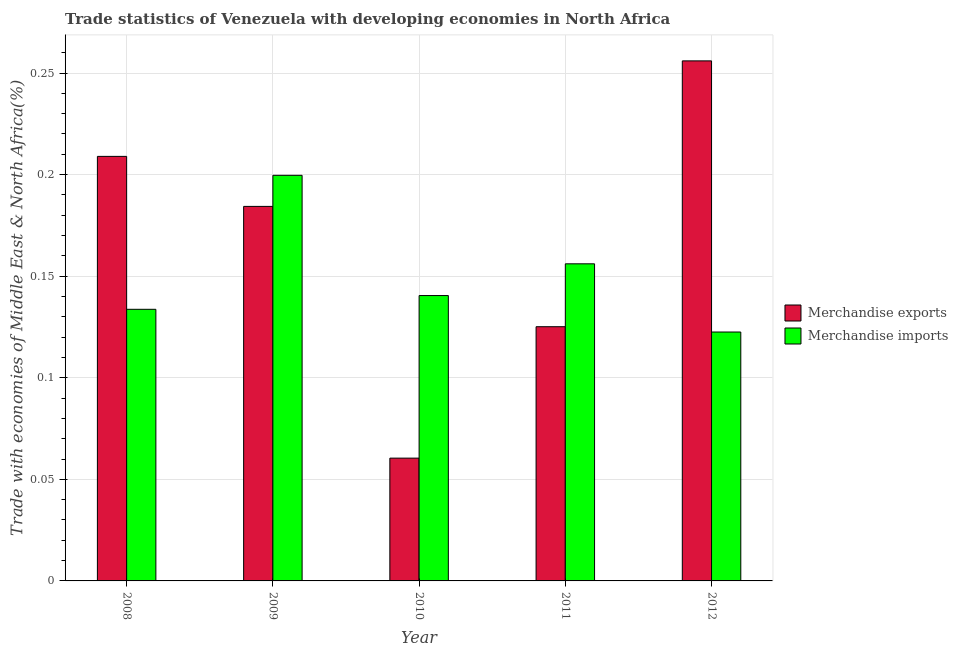Are the number of bars on each tick of the X-axis equal?
Provide a succinct answer. Yes. How many bars are there on the 3rd tick from the left?
Ensure brevity in your answer.  2. What is the label of the 2nd group of bars from the left?
Keep it short and to the point. 2009. What is the merchandise imports in 2010?
Ensure brevity in your answer.  0.14. Across all years, what is the maximum merchandise imports?
Provide a short and direct response. 0.2. Across all years, what is the minimum merchandise exports?
Ensure brevity in your answer.  0.06. In which year was the merchandise exports minimum?
Provide a short and direct response. 2010. What is the total merchandise imports in the graph?
Keep it short and to the point. 0.75. What is the difference between the merchandise imports in 2009 and that in 2010?
Give a very brief answer. 0.06. What is the difference between the merchandise imports in 2012 and the merchandise exports in 2008?
Ensure brevity in your answer.  -0.01. What is the average merchandise exports per year?
Provide a succinct answer. 0.17. What is the ratio of the merchandise exports in 2008 to that in 2009?
Make the answer very short. 1.13. What is the difference between the highest and the second highest merchandise imports?
Give a very brief answer. 0.04. What is the difference between the highest and the lowest merchandise imports?
Your response must be concise. 0.08. In how many years, is the merchandise imports greater than the average merchandise imports taken over all years?
Keep it short and to the point. 2. What does the 2nd bar from the left in 2008 represents?
Your answer should be very brief. Merchandise imports. What is the difference between two consecutive major ticks on the Y-axis?
Keep it short and to the point. 0.05. Are the values on the major ticks of Y-axis written in scientific E-notation?
Your answer should be very brief. No. How many legend labels are there?
Provide a succinct answer. 2. How are the legend labels stacked?
Provide a succinct answer. Vertical. What is the title of the graph?
Provide a short and direct response. Trade statistics of Venezuela with developing economies in North Africa. What is the label or title of the Y-axis?
Provide a short and direct response. Trade with economies of Middle East & North Africa(%). What is the Trade with economies of Middle East & North Africa(%) of Merchandise exports in 2008?
Your answer should be compact. 0.21. What is the Trade with economies of Middle East & North Africa(%) in Merchandise imports in 2008?
Your response must be concise. 0.13. What is the Trade with economies of Middle East & North Africa(%) in Merchandise exports in 2009?
Your response must be concise. 0.18. What is the Trade with economies of Middle East & North Africa(%) of Merchandise imports in 2009?
Ensure brevity in your answer.  0.2. What is the Trade with economies of Middle East & North Africa(%) of Merchandise exports in 2010?
Your answer should be very brief. 0.06. What is the Trade with economies of Middle East & North Africa(%) in Merchandise imports in 2010?
Your answer should be compact. 0.14. What is the Trade with economies of Middle East & North Africa(%) in Merchandise exports in 2011?
Make the answer very short. 0.13. What is the Trade with economies of Middle East & North Africa(%) of Merchandise imports in 2011?
Your response must be concise. 0.16. What is the Trade with economies of Middle East & North Africa(%) in Merchandise exports in 2012?
Keep it short and to the point. 0.26. What is the Trade with economies of Middle East & North Africa(%) in Merchandise imports in 2012?
Ensure brevity in your answer.  0.12. Across all years, what is the maximum Trade with economies of Middle East & North Africa(%) of Merchandise exports?
Your answer should be very brief. 0.26. Across all years, what is the maximum Trade with economies of Middle East & North Africa(%) of Merchandise imports?
Make the answer very short. 0.2. Across all years, what is the minimum Trade with economies of Middle East & North Africa(%) in Merchandise exports?
Offer a very short reply. 0.06. Across all years, what is the minimum Trade with economies of Middle East & North Africa(%) of Merchandise imports?
Ensure brevity in your answer.  0.12. What is the total Trade with economies of Middle East & North Africa(%) in Merchandise exports in the graph?
Give a very brief answer. 0.83. What is the total Trade with economies of Middle East & North Africa(%) in Merchandise imports in the graph?
Your answer should be compact. 0.75. What is the difference between the Trade with economies of Middle East & North Africa(%) of Merchandise exports in 2008 and that in 2009?
Ensure brevity in your answer.  0.02. What is the difference between the Trade with economies of Middle East & North Africa(%) in Merchandise imports in 2008 and that in 2009?
Provide a succinct answer. -0.07. What is the difference between the Trade with economies of Middle East & North Africa(%) of Merchandise exports in 2008 and that in 2010?
Your answer should be compact. 0.15. What is the difference between the Trade with economies of Middle East & North Africa(%) in Merchandise imports in 2008 and that in 2010?
Offer a very short reply. -0.01. What is the difference between the Trade with economies of Middle East & North Africa(%) of Merchandise exports in 2008 and that in 2011?
Your response must be concise. 0.08. What is the difference between the Trade with economies of Middle East & North Africa(%) in Merchandise imports in 2008 and that in 2011?
Your answer should be very brief. -0.02. What is the difference between the Trade with economies of Middle East & North Africa(%) of Merchandise exports in 2008 and that in 2012?
Keep it short and to the point. -0.05. What is the difference between the Trade with economies of Middle East & North Africa(%) in Merchandise imports in 2008 and that in 2012?
Ensure brevity in your answer.  0.01. What is the difference between the Trade with economies of Middle East & North Africa(%) of Merchandise exports in 2009 and that in 2010?
Your response must be concise. 0.12. What is the difference between the Trade with economies of Middle East & North Africa(%) in Merchandise imports in 2009 and that in 2010?
Make the answer very short. 0.06. What is the difference between the Trade with economies of Middle East & North Africa(%) of Merchandise exports in 2009 and that in 2011?
Offer a terse response. 0.06. What is the difference between the Trade with economies of Middle East & North Africa(%) in Merchandise imports in 2009 and that in 2011?
Offer a very short reply. 0.04. What is the difference between the Trade with economies of Middle East & North Africa(%) in Merchandise exports in 2009 and that in 2012?
Offer a very short reply. -0.07. What is the difference between the Trade with economies of Middle East & North Africa(%) in Merchandise imports in 2009 and that in 2012?
Provide a short and direct response. 0.08. What is the difference between the Trade with economies of Middle East & North Africa(%) in Merchandise exports in 2010 and that in 2011?
Give a very brief answer. -0.06. What is the difference between the Trade with economies of Middle East & North Africa(%) of Merchandise imports in 2010 and that in 2011?
Offer a very short reply. -0.02. What is the difference between the Trade with economies of Middle East & North Africa(%) of Merchandise exports in 2010 and that in 2012?
Your answer should be compact. -0.2. What is the difference between the Trade with economies of Middle East & North Africa(%) of Merchandise imports in 2010 and that in 2012?
Keep it short and to the point. 0.02. What is the difference between the Trade with economies of Middle East & North Africa(%) of Merchandise exports in 2011 and that in 2012?
Make the answer very short. -0.13. What is the difference between the Trade with economies of Middle East & North Africa(%) in Merchandise imports in 2011 and that in 2012?
Offer a terse response. 0.03. What is the difference between the Trade with economies of Middle East & North Africa(%) in Merchandise exports in 2008 and the Trade with economies of Middle East & North Africa(%) in Merchandise imports in 2009?
Offer a terse response. 0.01. What is the difference between the Trade with economies of Middle East & North Africa(%) of Merchandise exports in 2008 and the Trade with economies of Middle East & North Africa(%) of Merchandise imports in 2010?
Your answer should be very brief. 0.07. What is the difference between the Trade with economies of Middle East & North Africa(%) of Merchandise exports in 2008 and the Trade with economies of Middle East & North Africa(%) of Merchandise imports in 2011?
Your answer should be very brief. 0.05. What is the difference between the Trade with economies of Middle East & North Africa(%) in Merchandise exports in 2008 and the Trade with economies of Middle East & North Africa(%) in Merchandise imports in 2012?
Give a very brief answer. 0.09. What is the difference between the Trade with economies of Middle East & North Africa(%) in Merchandise exports in 2009 and the Trade with economies of Middle East & North Africa(%) in Merchandise imports in 2010?
Make the answer very short. 0.04. What is the difference between the Trade with economies of Middle East & North Africa(%) of Merchandise exports in 2009 and the Trade with economies of Middle East & North Africa(%) of Merchandise imports in 2011?
Your answer should be compact. 0.03. What is the difference between the Trade with economies of Middle East & North Africa(%) in Merchandise exports in 2009 and the Trade with economies of Middle East & North Africa(%) in Merchandise imports in 2012?
Offer a very short reply. 0.06. What is the difference between the Trade with economies of Middle East & North Africa(%) of Merchandise exports in 2010 and the Trade with economies of Middle East & North Africa(%) of Merchandise imports in 2011?
Provide a succinct answer. -0.1. What is the difference between the Trade with economies of Middle East & North Africa(%) of Merchandise exports in 2010 and the Trade with economies of Middle East & North Africa(%) of Merchandise imports in 2012?
Offer a very short reply. -0.06. What is the difference between the Trade with economies of Middle East & North Africa(%) of Merchandise exports in 2011 and the Trade with economies of Middle East & North Africa(%) of Merchandise imports in 2012?
Provide a short and direct response. 0. What is the average Trade with economies of Middle East & North Africa(%) in Merchandise exports per year?
Keep it short and to the point. 0.17. What is the average Trade with economies of Middle East & North Africa(%) of Merchandise imports per year?
Ensure brevity in your answer.  0.15. In the year 2008, what is the difference between the Trade with economies of Middle East & North Africa(%) of Merchandise exports and Trade with economies of Middle East & North Africa(%) of Merchandise imports?
Offer a terse response. 0.08. In the year 2009, what is the difference between the Trade with economies of Middle East & North Africa(%) in Merchandise exports and Trade with economies of Middle East & North Africa(%) in Merchandise imports?
Provide a succinct answer. -0.02. In the year 2010, what is the difference between the Trade with economies of Middle East & North Africa(%) in Merchandise exports and Trade with economies of Middle East & North Africa(%) in Merchandise imports?
Ensure brevity in your answer.  -0.08. In the year 2011, what is the difference between the Trade with economies of Middle East & North Africa(%) in Merchandise exports and Trade with economies of Middle East & North Africa(%) in Merchandise imports?
Offer a terse response. -0.03. In the year 2012, what is the difference between the Trade with economies of Middle East & North Africa(%) in Merchandise exports and Trade with economies of Middle East & North Africa(%) in Merchandise imports?
Give a very brief answer. 0.13. What is the ratio of the Trade with economies of Middle East & North Africa(%) of Merchandise exports in 2008 to that in 2009?
Keep it short and to the point. 1.13. What is the ratio of the Trade with economies of Middle East & North Africa(%) of Merchandise imports in 2008 to that in 2009?
Provide a short and direct response. 0.67. What is the ratio of the Trade with economies of Middle East & North Africa(%) in Merchandise exports in 2008 to that in 2010?
Provide a succinct answer. 3.46. What is the ratio of the Trade with economies of Middle East & North Africa(%) in Merchandise imports in 2008 to that in 2010?
Your answer should be compact. 0.95. What is the ratio of the Trade with economies of Middle East & North Africa(%) of Merchandise exports in 2008 to that in 2011?
Offer a very short reply. 1.67. What is the ratio of the Trade with economies of Middle East & North Africa(%) of Merchandise imports in 2008 to that in 2011?
Ensure brevity in your answer.  0.86. What is the ratio of the Trade with economies of Middle East & North Africa(%) of Merchandise exports in 2008 to that in 2012?
Your answer should be very brief. 0.82. What is the ratio of the Trade with economies of Middle East & North Africa(%) of Merchandise imports in 2008 to that in 2012?
Ensure brevity in your answer.  1.09. What is the ratio of the Trade with economies of Middle East & North Africa(%) of Merchandise exports in 2009 to that in 2010?
Offer a very short reply. 3.05. What is the ratio of the Trade with economies of Middle East & North Africa(%) in Merchandise imports in 2009 to that in 2010?
Make the answer very short. 1.42. What is the ratio of the Trade with economies of Middle East & North Africa(%) in Merchandise exports in 2009 to that in 2011?
Provide a short and direct response. 1.47. What is the ratio of the Trade with economies of Middle East & North Africa(%) in Merchandise imports in 2009 to that in 2011?
Give a very brief answer. 1.28. What is the ratio of the Trade with economies of Middle East & North Africa(%) in Merchandise exports in 2009 to that in 2012?
Offer a very short reply. 0.72. What is the ratio of the Trade with economies of Middle East & North Africa(%) in Merchandise imports in 2009 to that in 2012?
Offer a very short reply. 1.63. What is the ratio of the Trade with economies of Middle East & North Africa(%) of Merchandise exports in 2010 to that in 2011?
Give a very brief answer. 0.48. What is the ratio of the Trade with economies of Middle East & North Africa(%) in Merchandise imports in 2010 to that in 2011?
Keep it short and to the point. 0.9. What is the ratio of the Trade with economies of Middle East & North Africa(%) in Merchandise exports in 2010 to that in 2012?
Your answer should be very brief. 0.24. What is the ratio of the Trade with economies of Middle East & North Africa(%) in Merchandise imports in 2010 to that in 2012?
Give a very brief answer. 1.15. What is the ratio of the Trade with economies of Middle East & North Africa(%) of Merchandise exports in 2011 to that in 2012?
Offer a terse response. 0.49. What is the ratio of the Trade with economies of Middle East & North Africa(%) of Merchandise imports in 2011 to that in 2012?
Your answer should be compact. 1.27. What is the difference between the highest and the second highest Trade with economies of Middle East & North Africa(%) in Merchandise exports?
Your answer should be very brief. 0.05. What is the difference between the highest and the second highest Trade with economies of Middle East & North Africa(%) in Merchandise imports?
Make the answer very short. 0.04. What is the difference between the highest and the lowest Trade with economies of Middle East & North Africa(%) of Merchandise exports?
Provide a short and direct response. 0.2. What is the difference between the highest and the lowest Trade with economies of Middle East & North Africa(%) in Merchandise imports?
Your response must be concise. 0.08. 